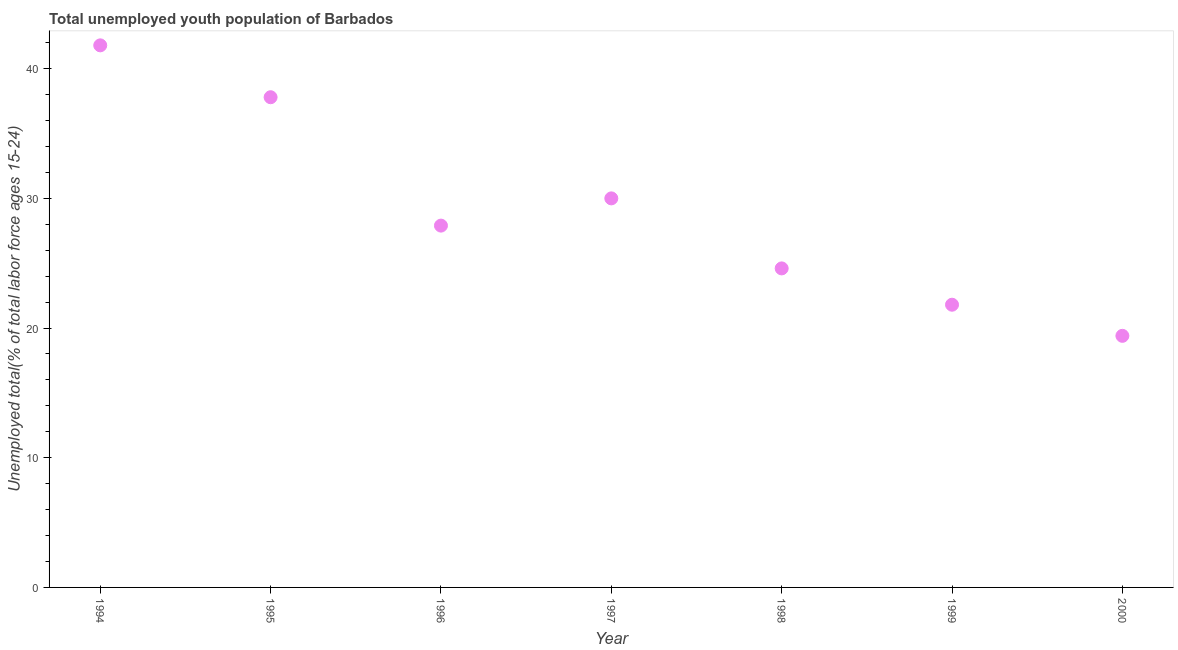What is the unemployed youth in 1995?
Your response must be concise. 37.8. Across all years, what is the maximum unemployed youth?
Your answer should be compact. 41.8. Across all years, what is the minimum unemployed youth?
Your answer should be very brief. 19.4. What is the sum of the unemployed youth?
Give a very brief answer. 203.3. What is the difference between the unemployed youth in 1994 and 1997?
Your response must be concise. 11.8. What is the average unemployed youth per year?
Your answer should be very brief. 29.04. What is the median unemployed youth?
Ensure brevity in your answer.  27.9. In how many years, is the unemployed youth greater than 8 %?
Ensure brevity in your answer.  7. What is the ratio of the unemployed youth in 1994 to that in 1997?
Your answer should be very brief. 1.39. Is the unemployed youth in 1997 less than that in 1998?
Make the answer very short. No. What is the difference between the highest and the second highest unemployed youth?
Your answer should be very brief. 4. What is the difference between the highest and the lowest unemployed youth?
Your response must be concise. 22.4. In how many years, is the unemployed youth greater than the average unemployed youth taken over all years?
Your response must be concise. 3. How many dotlines are there?
Offer a very short reply. 1. How many years are there in the graph?
Your response must be concise. 7. What is the difference between two consecutive major ticks on the Y-axis?
Give a very brief answer. 10. Are the values on the major ticks of Y-axis written in scientific E-notation?
Ensure brevity in your answer.  No. Does the graph contain any zero values?
Ensure brevity in your answer.  No. What is the title of the graph?
Your response must be concise. Total unemployed youth population of Barbados. What is the label or title of the Y-axis?
Provide a short and direct response. Unemployed total(% of total labor force ages 15-24). What is the Unemployed total(% of total labor force ages 15-24) in 1994?
Your answer should be compact. 41.8. What is the Unemployed total(% of total labor force ages 15-24) in 1995?
Your answer should be very brief. 37.8. What is the Unemployed total(% of total labor force ages 15-24) in 1996?
Your response must be concise. 27.9. What is the Unemployed total(% of total labor force ages 15-24) in 1998?
Provide a succinct answer. 24.6. What is the Unemployed total(% of total labor force ages 15-24) in 1999?
Your response must be concise. 21.8. What is the Unemployed total(% of total labor force ages 15-24) in 2000?
Your answer should be very brief. 19.4. What is the difference between the Unemployed total(% of total labor force ages 15-24) in 1994 and 1998?
Offer a terse response. 17.2. What is the difference between the Unemployed total(% of total labor force ages 15-24) in 1994 and 1999?
Provide a short and direct response. 20. What is the difference between the Unemployed total(% of total labor force ages 15-24) in 1994 and 2000?
Make the answer very short. 22.4. What is the difference between the Unemployed total(% of total labor force ages 15-24) in 1995 and 1997?
Provide a short and direct response. 7.8. What is the difference between the Unemployed total(% of total labor force ages 15-24) in 1995 and 1998?
Ensure brevity in your answer.  13.2. What is the difference between the Unemployed total(% of total labor force ages 15-24) in 1995 and 1999?
Your answer should be compact. 16. What is the difference between the Unemployed total(% of total labor force ages 15-24) in 1995 and 2000?
Offer a very short reply. 18.4. What is the difference between the Unemployed total(% of total labor force ages 15-24) in 1996 and 1997?
Offer a terse response. -2.1. What is the difference between the Unemployed total(% of total labor force ages 15-24) in 1996 and 1999?
Give a very brief answer. 6.1. What is the difference between the Unemployed total(% of total labor force ages 15-24) in 1997 and 1998?
Make the answer very short. 5.4. What is the difference between the Unemployed total(% of total labor force ages 15-24) in 1998 and 1999?
Make the answer very short. 2.8. What is the difference between the Unemployed total(% of total labor force ages 15-24) in 1999 and 2000?
Offer a very short reply. 2.4. What is the ratio of the Unemployed total(% of total labor force ages 15-24) in 1994 to that in 1995?
Offer a very short reply. 1.11. What is the ratio of the Unemployed total(% of total labor force ages 15-24) in 1994 to that in 1996?
Your answer should be compact. 1.5. What is the ratio of the Unemployed total(% of total labor force ages 15-24) in 1994 to that in 1997?
Your answer should be very brief. 1.39. What is the ratio of the Unemployed total(% of total labor force ages 15-24) in 1994 to that in 1998?
Make the answer very short. 1.7. What is the ratio of the Unemployed total(% of total labor force ages 15-24) in 1994 to that in 1999?
Provide a short and direct response. 1.92. What is the ratio of the Unemployed total(% of total labor force ages 15-24) in 1994 to that in 2000?
Ensure brevity in your answer.  2.15. What is the ratio of the Unemployed total(% of total labor force ages 15-24) in 1995 to that in 1996?
Offer a terse response. 1.35. What is the ratio of the Unemployed total(% of total labor force ages 15-24) in 1995 to that in 1997?
Ensure brevity in your answer.  1.26. What is the ratio of the Unemployed total(% of total labor force ages 15-24) in 1995 to that in 1998?
Keep it short and to the point. 1.54. What is the ratio of the Unemployed total(% of total labor force ages 15-24) in 1995 to that in 1999?
Your response must be concise. 1.73. What is the ratio of the Unemployed total(% of total labor force ages 15-24) in 1995 to that in 2000?
Offer a terse response. 1.95. What is the ratio of the Unemployed total(% of total labor force ages 15-24) in 1996 to that in 1997?
Offer a terse response. 0.93. What is the ratio of the Unemployed total(% of total labor force ages 15-24) in 1996 to that in 1998?
Ensure brevity in your answer.  1.13. What is the ratio of the Unemployed total(% of total labor force ages 15-24) in 1996 to that in 1999?
Offer a very short reply. 1.28. What is the ratio of the Unemployed total(% of total labor force ages 15-24) in 1996 to that in 2000?
Your answer should be compact. 1.44. What is the ratio of the Unemployed total(% of total labor force ages 15-24) in 1997 to that in 1998?
Offer a terse response. 1.22. What is the ratio of the Unemployed total(% of total labor force ages 15-24) in 1997 to that in 1999?
Your answer should be very brief. 1.38. What is the ratio of the Unemployed total(% of total labor force ages 15-24) in 1997 to that in 2000?
Ensure brevity in your answer.  1.55. What is the ratio of the Unemployed total(% of total labor force ages 15-24) in 1998 to that in 1999?
Ensure brevity in your answer.  1.13. What is the ratio of the Unemployed total(% of total labor force ages 15-24) in 1998 to that in 2000?
Provide a succinct answer. 1.27. What is the ratio of the Unemployed total(% of total labor force ages 15-24) in 1999 to that in 2000?
Give a very brief answer. 1.12. 